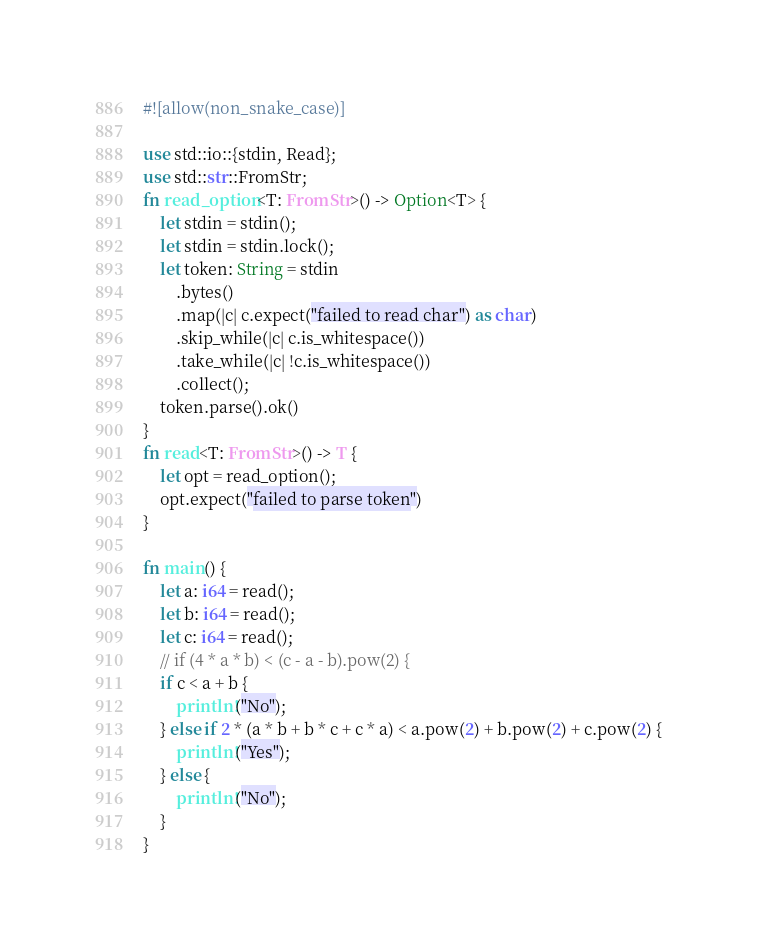<code> <loc_0><loc_0><loc_500><loc_500><_Rust_>#![allow(non_snake_case)]

use std::io::{stdin, Read};
use std::str::FromStr;
fn read_option<T: FromStr>() -> Option<T> {
    let stdin = stdin();
    let stdin = stdin.lock();
    let token: String = stdin
        .bytes()
        .map(|c| c.expect("failed to read char") as char)
        .skip_while(|c| c.is_whitespace())
        .take_while(|c| !c.is_whitespace())
        .collect();
    token.parse().ok()
}
fn read<T: FromStr>() -> T {
    let opt = read_option();
    opt.expect("failed to parse token")
}

fn main() {
    let a: i64 = read();
    let b: i64 = read();
    let c: i64 = read();
    // if (4 * a * b) < (c - a - b).pow(2) {
    if c < a + b {
        println!("No");
    } else if 2 * (a * b + b * c + c * a) < a.pow(2) + b.pow(2) + c.pow(2) {
        println!("Yes");
    } else {
        println!("No");
    }
}
</code> 